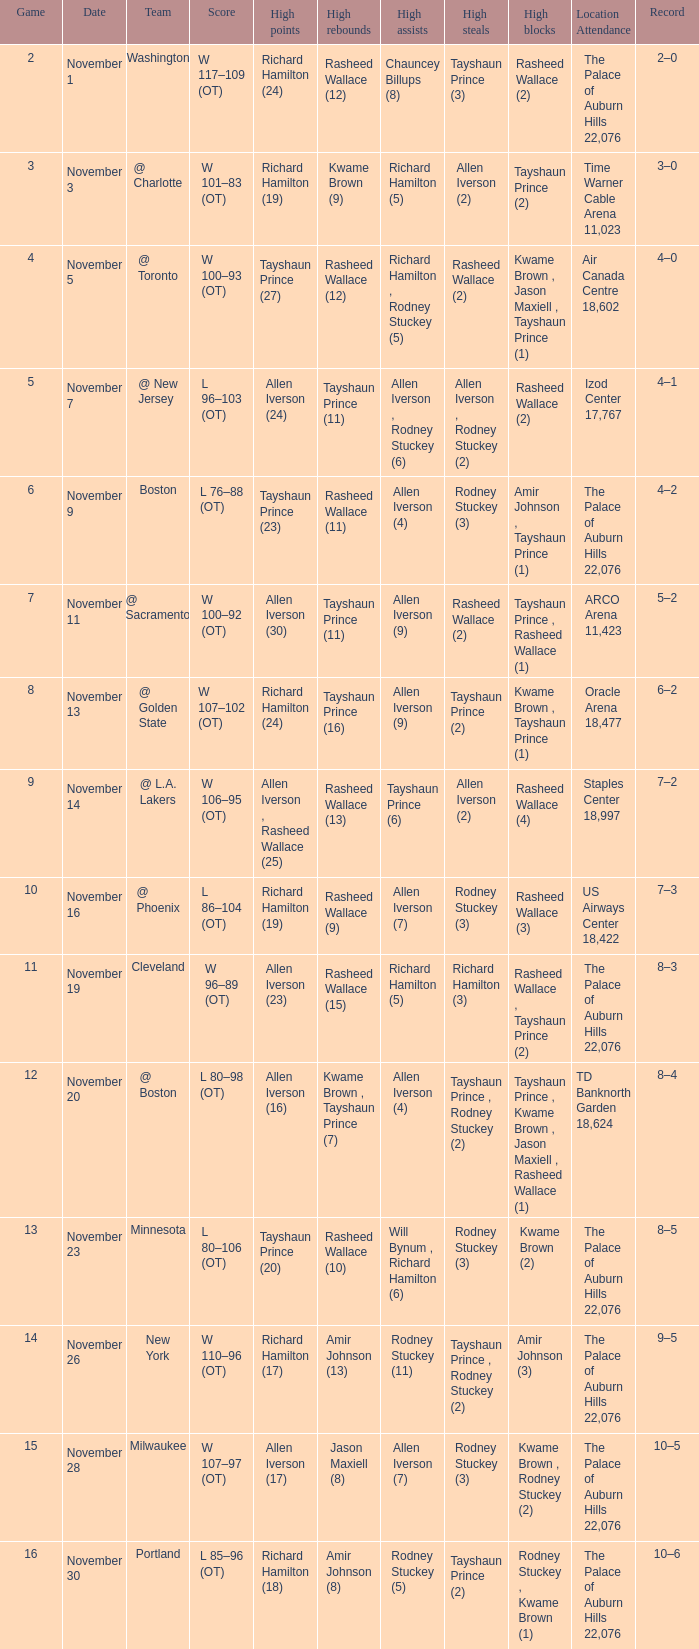What is Location Attendance, when High Points is "Allen Iverson (23)"? The Palace of Auburn Hills 22,076. 